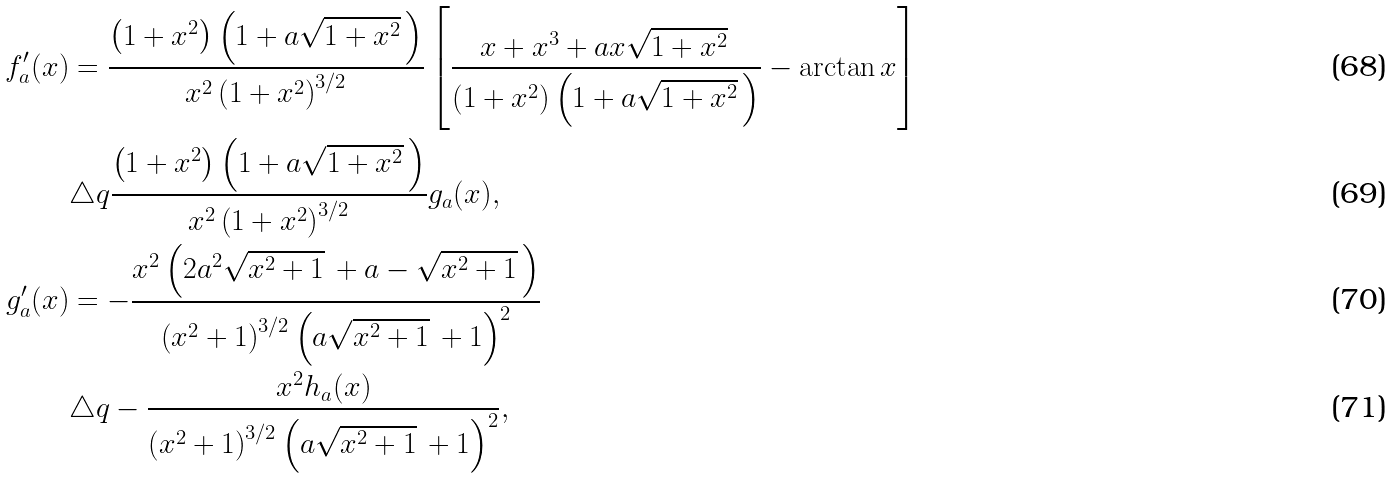<formula> <loc_0><loc_0><loc_500><loc_500>f ^ { \prime } _ { a } ( x ) & = \frac { \left ( 1 + x ^ { 2 } \right ) \left ( 1 + a \sqrt { 1 + x ^ { 2 } } \, \right ) } { x ^ { 2 } \left ( 1 + x ^ { 2 } \right ) ^ { 3 / 2 } } \left [ \frac { x + x ^ { 3 } + a x \sqrt { 1 + x ^ { 2 } } \, } { \left ( 1 + x ^ { 2 } \right ) \left ( 1 + a \sqrt { 1 + x ^ { 2 } } \, \right ) } - \arctan x \right ] \\ & \triangle q \frac { \left ( 1 + x ^ { 2 } \right ) \left ( 1 + a \sqrt { 1 + x ^ { 2 } } \, \right ) } { x ^ { 2 } \left ( 1 + x ^ { 2 } \right ) ^ { 3 / 2 } } g _ { a } ( x ) , \\ g ^ { \prime } _ { a } ( x ) & = - \frac { x ^ { 2 } \left ( 2 a ^ { 2 } \sqrt { x ^ { 2 } + 1 } \, + a - \sqrt { x ^ { 2 } + 1 } \, \right ) } { \left ( x ^ { 2 } + 1 \right ) ^ { 3 / 2 } \left ( a \sqrt { x ^ { 2 } + 1 } \, + 1 \right ) ^ { 2 } } \\ & \triangle q - \frac { x ^ { 2 } h _ { a } ( x ) } { \left ( x ^ { 2 } + 1 \right ) ^ { 3 / 2 } \left ( a \sqrt { x ^ { 2 } + 1 } \, + 1 \right ) ^ { 2 } } ,</formula> 